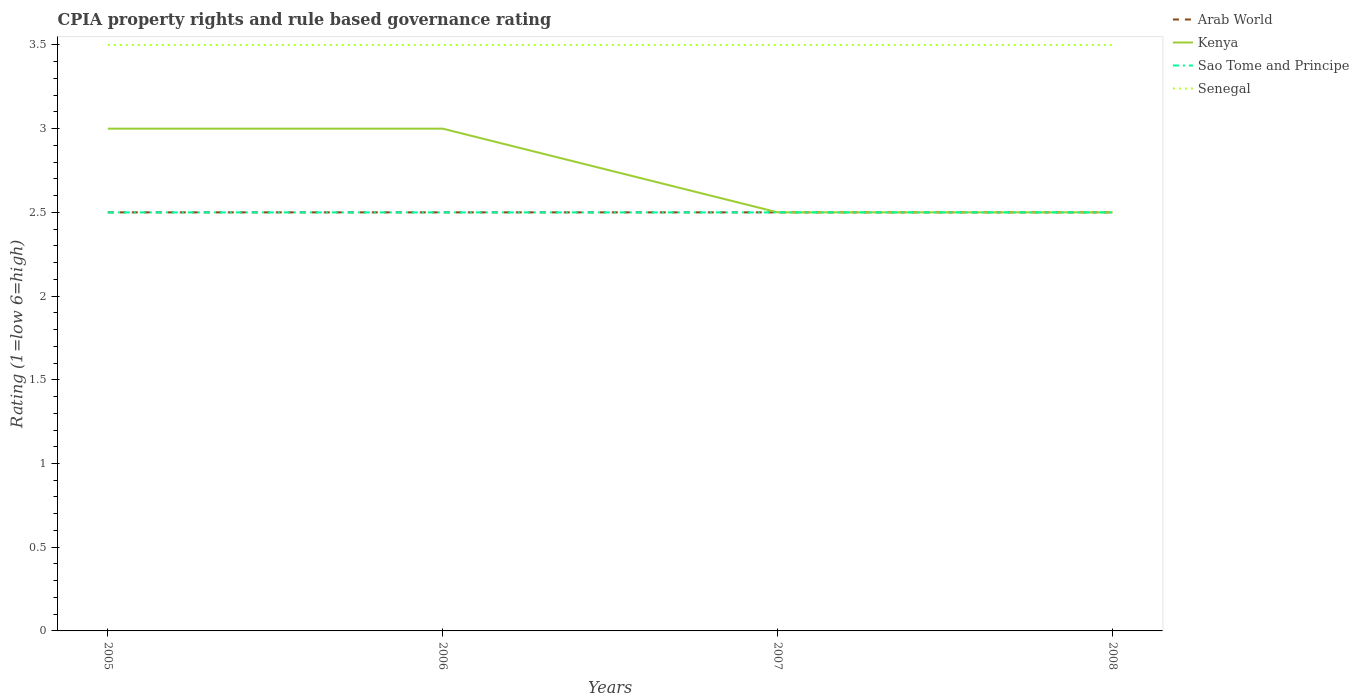How many different coloured lines are there?
Provide a short and direct response. 4. Does the line corresponding to Arab World intersect with the line corresponding to Kenya?
Provide a succinct answer. Yes. Is the number of lines equal to the number of legend labels?
Offer a terse response. Yes. In which year was the CPIA rating in Sao Tome and Principe maximum?
Your answer should be compact. 2005. Is the CPIA rating in Senegal strictly greater than the CPIA rating in Sao Tome and Principe over the years?
Give a very brief answer. No. Are the values on the major ticks of Y-axis written in scientific E-notation?
Your answer should be very brief. No. Does the graph contain grids?
Make the answer very short. No. Where does the legend appear in the graph?
Make the answer very short. Top right. How many legend labels are there?
Offer a very short reply. 4. What is the title of the graph?
Give a very brief answer. CPIA property rights and rule based governance rating. What is the label or title of the Y-axis?
Offer a terse response. Rating (1=low 6=high). What is the Rating (1=low 6=high) of Kenya in 2005?
Provide a succinct answer. 3. What is the Rating (1=low 6=high) of Sao Tome and Principe in 2005?
Provide a succinct answer. 2.5. What is the Rating (1=low 6=high) in Senegal in 2005?
Provide a succinct answer. 3.5. What is the Rating (1=low 6=high) in Kenya in 2006?
Your answer should be compact. 3. What is the Rating (1=low 6=high) of Kenya in 2007?
Give a very brief answer. 2.5. What is the Rating (1=low 6=high) of Arab World in 2008?
Your answer should be compact. 2.5. What is the Rating (1=low 6=high) of Kenya in 2008?
Your answer should be very brief. 2.5. What is the Rating (1=low 6=high) of Sao Tome and Principe in 2008?
Your answer should be compact. 2.5. Across all years, what is the maximum Rating (1=low 6=high) of Sao Tome and Principe?
Your response must be concise. 2.5. Across all years, what is the minimum Rating (1=low 6=high) of Arab World?
Offer a very short reply. 2.5. Across all years, what is the minimum Rating (1=low 6=high) of Kenya?
Your answer should be very brief. 2.5. Across all years, what is the minimum Rating (1=low 6=high) of Senegal?
Give a very brief answer. 3.5. What is the total Rating (1=low 6=high) of Sao Tome and Principe in the graph?
Keep it short and to the point. 10. What is the total Rating (1=low 6=high) in Senegal in the graph?
Make the answer very short. 14. What is the difference between the Rating (1=low 6=high) in Kenya in 2005 and that in 2006?
Ensure brevity in your answer.  0. What is the difference between the Rating (1=low 6=high) of Senegal in 2005 and that in 2006?
Your answer should be compact. 0. What is the difference between the Rating (1=low 6=high) in Kenya in 2005 and that in 2007?
Offer a terse response. 0.5. What is the difference between the Rating (1=low 6=high) of Sao Tome and Principe in 2005 and that in 2007?
Your answer should be very brief. 0. What is the difference between the Rating (1=low 6=high) in Arab World in 2005 and that in 2008?
Your answer should be very brief. 0. What is the difference between the Rating (1=low 6=high) of Sao Tome and Principe in 2005 and that in 2008?
Offer a terse response. 0. What is the difference between the Rating (1=low 6=high) of Sao Tome and Principe in 2006 and that in 2007?
Offer a terse response. 0. What is the difference between the Rating (1=low 6=high) in Senegal in 2006 and that in 2007?
Ensure brevity in your answer.  0. What is the difference between the Rating (1=low 6=high) of Arab World in 2006 and that in 2008?
Provide a short and direct response. 0. What is the difference between the Rating (1=low 6=high) in Sao Tome and Principe in 2006 and that in 2008?
Give a very brief answer. 0. What is the difference between the Rating (1=low 6=high) of Arab World in 2007 and that in 2008?
Provide a short and direct response. 0. What is the difference between the Rating (1=low 6=high) of Kenya in 2007 and that in 2008?
Provide a short and direct response. 0. What is the difference between the Rating (1=low 6=high) in Senegal in 2007 and that in 2008?
Provide a succinct answer. 0. What is the difference between the Rating (1=low 6=high) of Arab World in 2005 and the Rating (1=low 6=high) of Kenya in 2006?
Make the answer very short. -0.5. What is the difference between the Rating (1=low 6=high) of Kenya in 2005 and the Rating (1=low 6=high) of Sao Tome and Principe in 2006?
Your response must be concise. 0.5. What is the difference between the Rating (1=low 6=high) in Kenya in 2005 and the Rating (1=low 6=high) in Senegal in 2006?
Offer a very short reply. -0.5. What is the difference between the Rating (1=low 6=high) in Arab World in 2005 and the Rating (1=low 6=high) in Kenya in 2007?
Provide a short and direct response. 0. What is the difference between the Rating (1=low 6=high) of Kenya in 2005 and the Rating (1=low 6=high) of Senegal in 2007?
Offer a terse response. -0.5. What is the difference between the Rating (1=low 6=high) of Arab World in 2005 and the Rating (1=low 6=high) of Kenya in 2008?
Ensure brevity in your answer.  0. What is the difference between the Rating (1=low 6=high) in Arab World in 2005 and the Rating (1=low 6=high) in Senegal in 2008?
Your response must be concise. -1. What is the difference between the Rating (1=low 6=high) in Kenya in 2005 and the Rating (1=low 6=high) in Sao Tome and Principe in 2008?
Keep it short and to the point. 0.5. What is the difference between the Rating (1=low 6=high) in Kenya in 2005 and the Rating (1=low 6=high) in Senegal in 2008?
Make the answer very short. -0.5. What is the difference between the Rating (1=low 6=high) of Sao Tome and Principe in 2005 and the Rating (1=low 6=high) of Senegal in 2008?
Your response must be concise. -1. What is the difference between the Rating (1=low 6=high) of Arab World in 2006 and the Rating (1=low 6=high) of Sao Tome and Principe in 2007?
Ensure brevity in your answer.  0. What is the difference between the Rating (1=low 6=high) of Arab World in 2006 and the Rating (1=low 6=high) of Senegal in 2008?
Give a very brief answer. -1. What is the difference between the Rating (1=low 6=high) in Kenya in 2006 and the Rating (1=low 6=high) in Sao Tome and Principe in 2008?
Keep it short and to the point. 0.5. What is the difference between the Rating (1=low 6=high) of Sao Tome and Principe in 2006 and the Rating (1=low 6=high) of Senegal in 2008?
Provide a short and direct response. -1. What is the difference between the Rating (1=low 6=high) of Arab World in 2007 and the Rating (1=low 6=high) of Kenya in 2008?
Make the answer very short. 0. What is the difference between the Rating (1=low 6=high) in Arab World in 2007 and the Rating (1=low 6=high) in Senegal in 2008?
Your response must be concise. -1. What is the difference between the Rating (1=low 6=high) in Kenya in 2007 and the Rating (1=low 6=high) in Senegal in 2008?
Provide a succinct answer. -1. What is the average Rating (1=low 6=high) in Arab World per year?
Offer a very short reply. 2.5. What is the average Rating (1=low 6=high) of Kenya per year?
Offer a very short reply. 2.75. What is the average Rating (1=low 6=high) of Sao Tome and Principe per year?
Keep it short and to the point. 2.5. What is the average Rating (1=low 6=high) in Senegal per year?
Provide a succinct answer. 3.5. In the year 2005, what is the difference between the Rating (1=low 6=high) in Arab World and Rating (1=low 6=high) in Kenya?
Your answer should be very brief. -0.5. In the year 2005, what is the difference between the Rating (1=low 6=high) of Arab World and Rating (1=low 6=high) of Sao Tome and Principe?
Ensure brevity in your answer.  0. In the year 2005, what is the difference between the Rating (1=low 6=high) in Arab World and Rating (1=low 6=high) in Senegal?
Your answer should be very brief. -1. In the year 2005, what is the difference between the Rating (1=low 6=high) of Kenya and Rating (1=low 6=high) of Sao Tome and Principe?
Your answer should be compact. 0.5. In the year 2005, what is the difference between the Rating (1=low 6=high) of Kenya and Rating (1=low 6=high) of Senegal?
Your answer should be very brief. -0.5. In the year 2005, what is the difference between the Rating (1=low 6=high) of Sao Tome and Principe and Rating (1=low 6=high) of Senegal?
Give a very brief answer. -1. In the year 2006, what is the difference between the Rating (1=low 6=high) of Arab World and Rating (1=low 6=high) of Sao Tome and Principe?
Ensure brevity in your answer.  0. In the year 2006, what is the difference between the Rating (1=low 6=high) of Kenya and Rating (1=low 6=high) of Sao Tome and Principe?
Make the answer very short. 0.5. In the year 2006, what is the difference between the Rating (1=low 6=high) of Sao Tome and Principe and Rating (1=low 6=high) of Senegal?
Your response must be concise. -1. In the year 2007, what is the difference between the Rating (1=low 6=high) of Kenya and Rating (1=low 6=high) of Senegal?
Provide a short and direct response. -1. In the year 2008, what is the difference between the Rating (1=low 6=high) in Sao Tome and Principe and Rating (1=low 6=high) in Senegal?
Make the answer very short. -1. What is the ratio of the Rating (1=low 6=high) in Arab World in 2005 to that in 2006?
Your answer should be very brief. 1. What is the ratio of the Rating (1=low 6=high) in Kenya in 2005 to that in 2006?
Provide a short and direct response. 1. What is the ratio of the Rating (1=low 6=high) in Sao Tome and Principe in 2005 to that in 2006?
Provide a short and direct response. 1. What is the ratio of the Rating (1=low 6=high) of Arab World in 2005 to that in 2007?
Provide a succinct answer. 1. What is the ratio of the Rating (1=low 6=high) of Kenya in 2005 to that in 2007?
Give a very brief answer. 1.2. What is the ratio of the Rating (1=low 6=high) of Senegal in 2005 to that in 2007?
Offer a terse response. 1. What is the ratio of the Rating (1=low 6=high) of Kenya in 2005 to that in 2008?
Provide a succinct answer. 1.2. What is the ratio of the Rating (1=low 6=high) in Senegal in 2005 to that in 2008?
Your answer should be very brief. 1. What is the ratio of the Rating (1=low 6=high) in Kenya in 2006 to that in 2007?
Keep it short and to the point. 1.2. What is the ratio of the Rating (1=low 6=high) in Sao Tome and Principe in 2006 to that in 2007?
Provide a succinct answer. 1. What is the ratio of the Rating (1=low 6=high) of Arab World in 2006 to that in 2008?
Make the answer very short. 1. What is the ratio of the Rating (1=low 6=high) in Kenya in 2006 to that in 2008?
Your answer should be compact. 1.2. What is the ratio of the Rating (1=low 6=high) in Sao Tome and Principe in 2006 to that in 2008?
Your answer should be very brief. 1. What is the ratio of the Rating (1=low 6=high) in Senegal in 2006 to that in 2008?
Ensure brevity in your answer.  1. What is the ratio of the Rating (1=low 6=high) in Sao Tome and Principe in 2007 to that in 2008?
Ensure brevity in your answer.  1. What is the ratio of the Rating (1=low 6=high) in Senegal in 2007 to that in 2008?
Provide a succinct answer. 1. What is the difference between the highest and the second highest Rating (1=low 6=high) in Kenya?
Your answer should be compact. 0. What is the difference between the highest and the lowest Rating (1=low 6=high) in Arab World?
Your response must be concise. 0. What is the difference between the highest and the lowest Rating (1=low 6=high) in Kenya?
Provide a succinct answer. 0.5. What is the difference between the highest and the lowest Rating (1=low 6=high) of Sao Tome and Principe?
Make the answer very short. 0. 